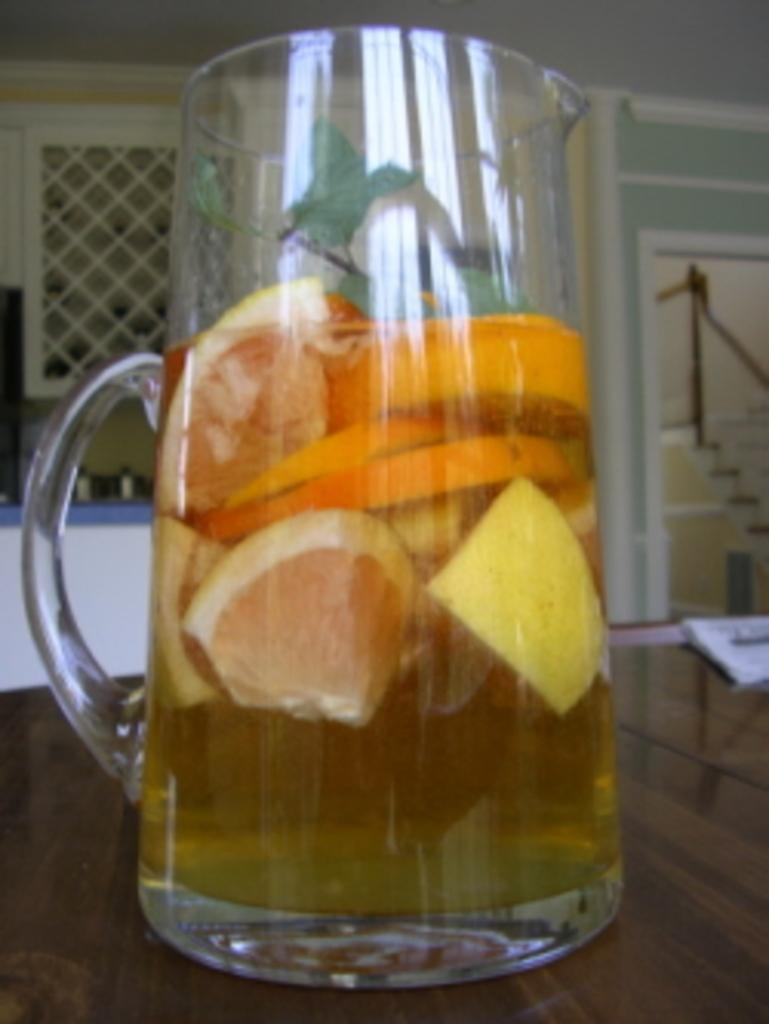What is in the glass that is visible in the image? There is a glass of lemon juice in the image. Where is the glass placed in the image? The glass is on a wooden table. What else can be seen on the table in the image? There are papers on the table on the right side. What is located on the left side of the image? There is a metal grill fence on the left side of the image. What type of orange is being used to solve the riddle in the image? There is no orange or riddle present in the image. 